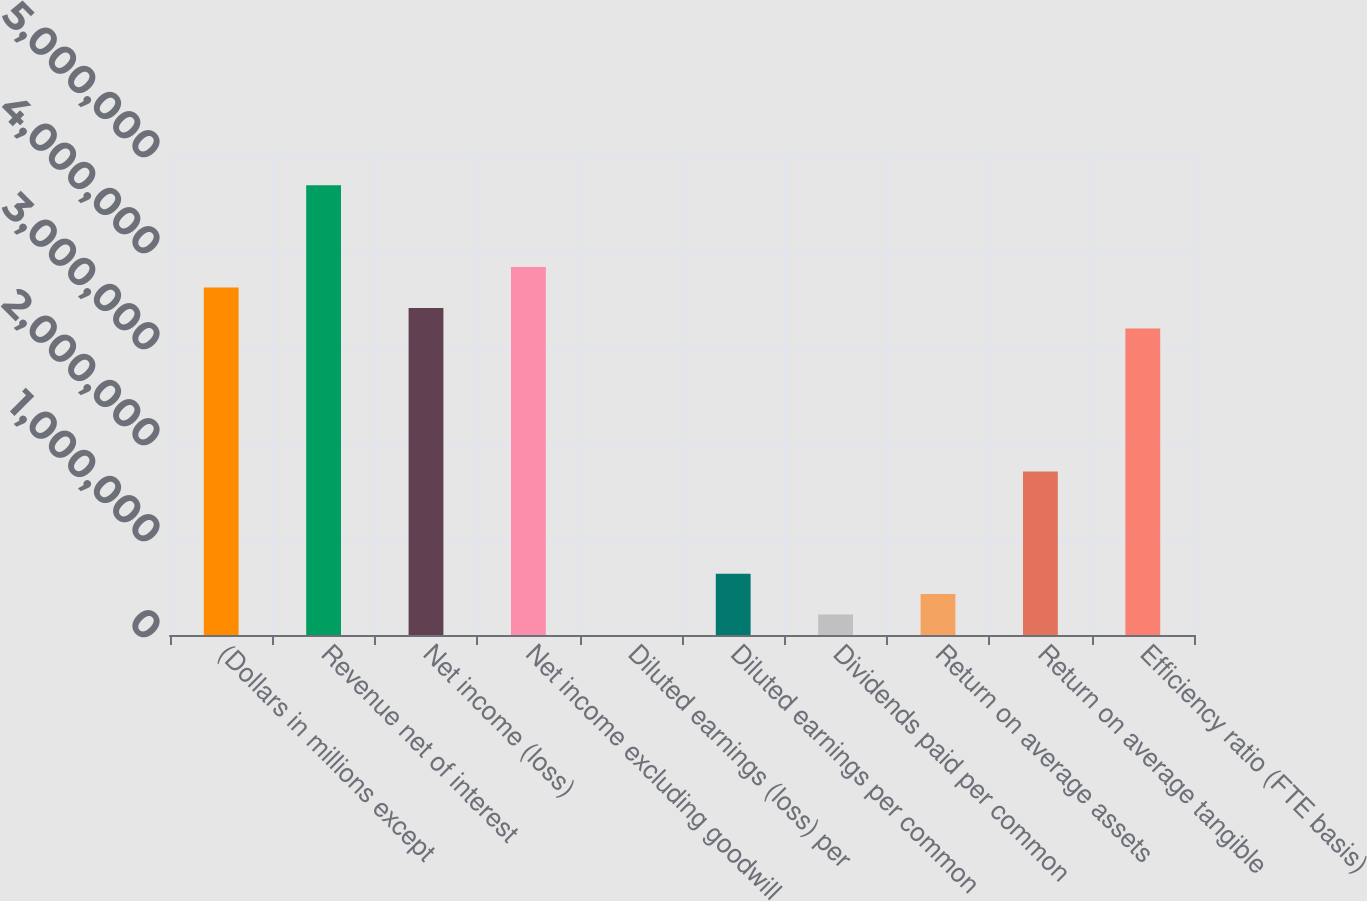Convert chart. <chart><loc_0><loc_0><loc_500><loc_500><bar_chart><fcel>(Dollars in millions except<fcel>Revenue net of interest<fcel>Net income (loss)<fcel>Net income excluding goodwill<fcel>Diluted earnings (loss) per<fcel>Diluted earnings per common<fcel>Dividends paid per common<fcel>Return on average assets<fcel>Return on average tangible<fcel>Efficiency ratio (FTE basis)<nl><fcel>3.61938e+06<fcel>4.6839e+06<fcel>3.40647e+06<fcel>3.83228e+06<fcel>0.01<fcel>638714<fcel>212905<fcel>425809<fcel>1.70324e+06<fcel>3.19357e+06<nl></chart> 